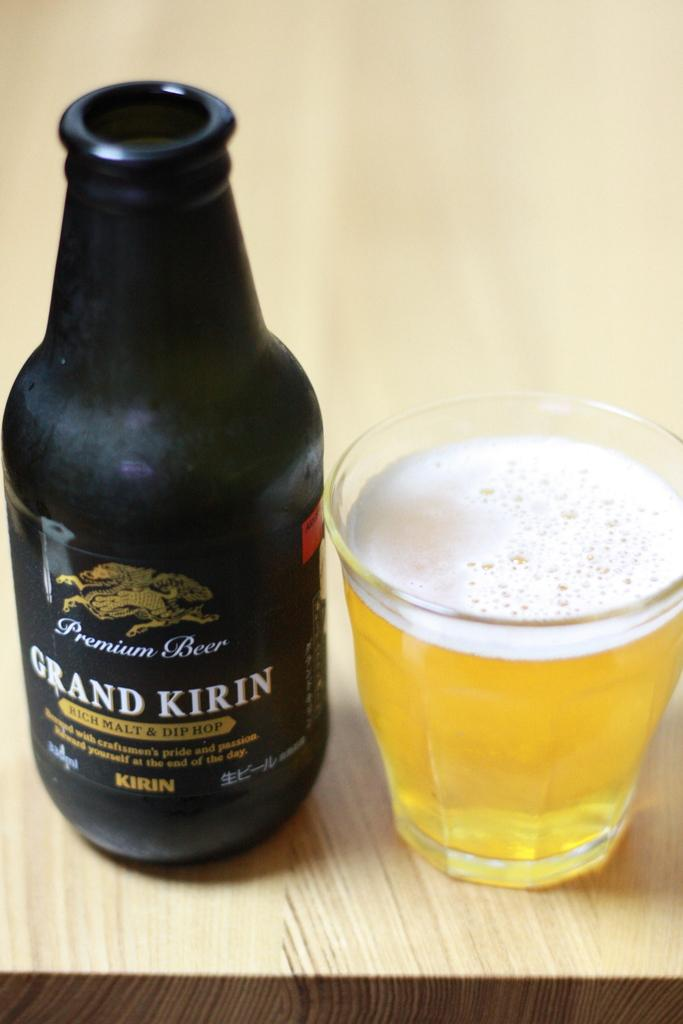<image>
Relay a brief, clear account of the picture shown. Bottle of Grand Kirin premium Beer that contains rich malt and dip hop. 